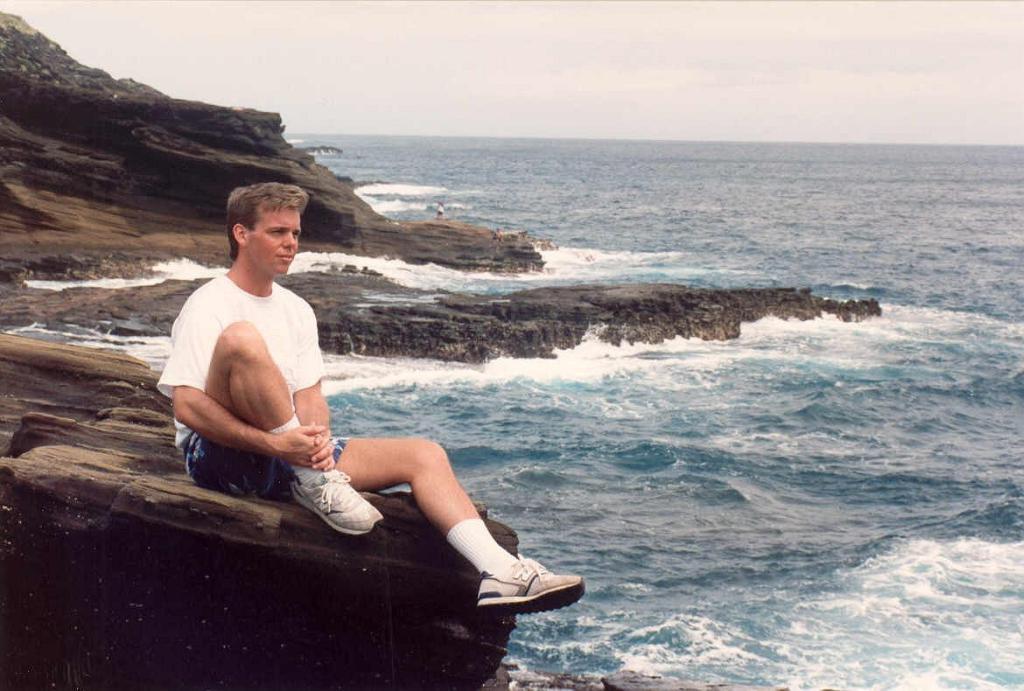How would you summarize this image in a sentence or two? In this image I can see the person with white and blue color dress. I can see the person sitting on the rock. In-front of the person I can see the water. In the background I can see the sky. 